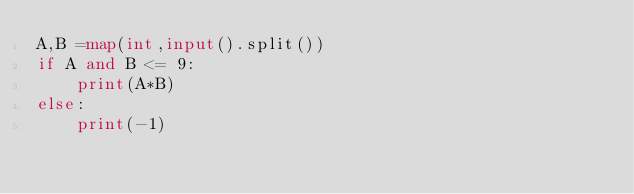<code> <loc_0><loc_0><loc_500><loc_500><_Python_>A,B =map(int,input().split())
if A and B <= 9:
    print(A*B)
else:
    print(-1)</code> 